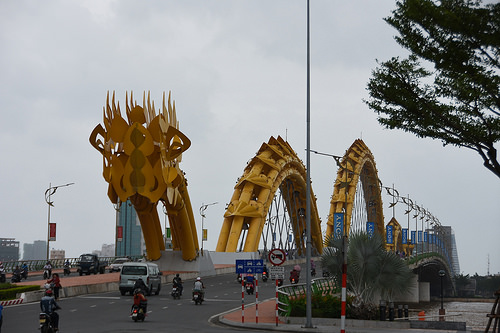<image>
Is there a art on the bridge? Yes. Looking at the image, I can see the art is positioned on top of the bridge, with the bridge providing support. 